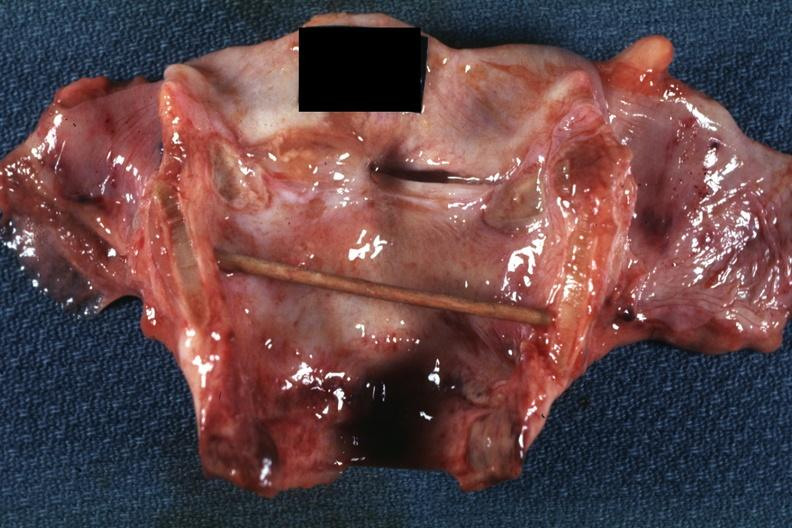s ulcer present?
Answer the question using a single word or phrase. Yes 